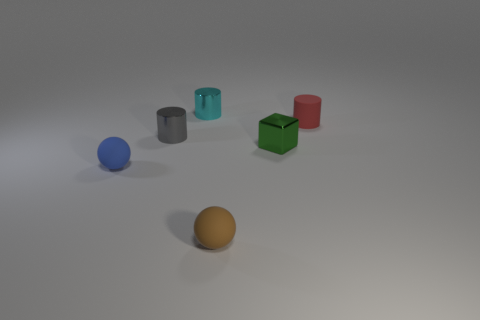What is the apparent material of the objects in the image? The objects in the image seem to be made from different materials. The spherical objects, a blue one and an orange one, have a matte finish indicative of plastic or rubber. The cylinders, one gray and one teal, seem to have a metallic luster. 